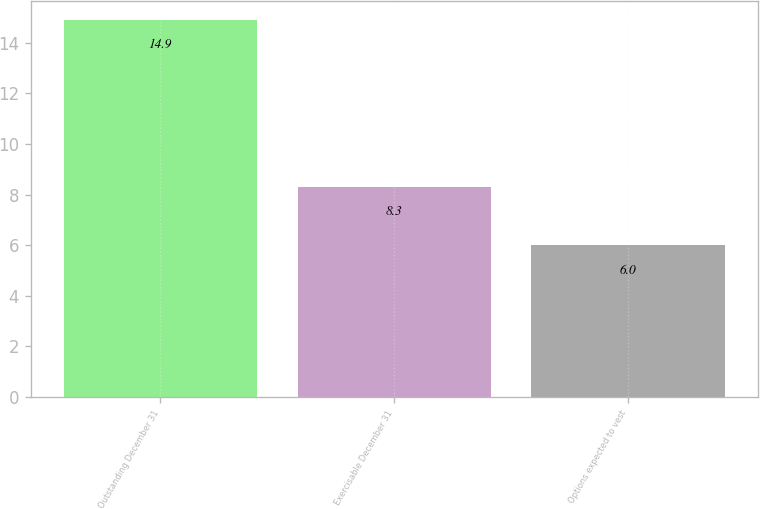<chart> <loc_0><loc_0><loc_500><loc_500><bar_chart><fcel>Outstanding December 31<fcel>Exercisable December 31<fcel>Options expected to vest<nl><fcel>14.9<fcel>8.3<fcel>6<nl></chart> 